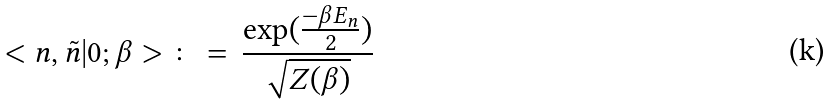<formula> <loc_0><loc_0><loc_500><loc_500>< n , \tilde { n } | 0 ; \beta > \, \colon = \, \frac { \exp ( \frac { - \beta E _ { n } } { 2 } ) } { \sqrt { Z ( \beta ) } }</formula> 